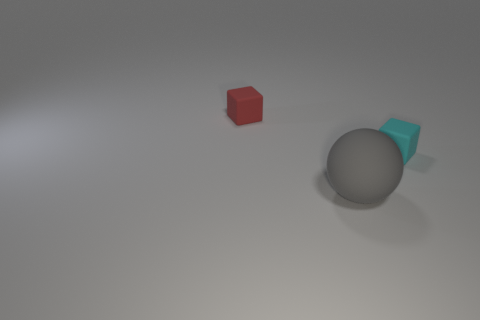Is the number of big matte spheres to the left of the small red matte thing less than the number of rubber balls that are behind the big sphere?
Ensure brevity in your answer.  No. Do the cyan thing and the matte object left of the gray rubber ball have the same size?
Make the answer very short. Yes. How many red things are the same size as the cyan object?
Offer a very short reply. 1. What number of big objects are either red rubber objects or blue cylinders?
Your answer should be very brief. 0. Is there a red block?
Make the answer very short. Yes. Is the number of small cyan matte things that are in front of the gray rubber sphere greater than the number of tiny cyan rubber cubes in front of the cyan object?
Give a very brief answer. No. There is a tiny matte thing that is left of the small object that is on the right side of the big ball; what color is it?
Your answer should be very brief. Red. Are there any matte cubes of the same color as the rubber sphere?
Ensure brevity in your answer.  No. How big is the gray rubber sphere that is in front of the tiny block on the right side of the tiny matte block that is left of the tiny cyan matte block?
Give a very brief answer. Large. There is a red thing; what shape is it?
Ensure brevity in your answer.  Cube. 